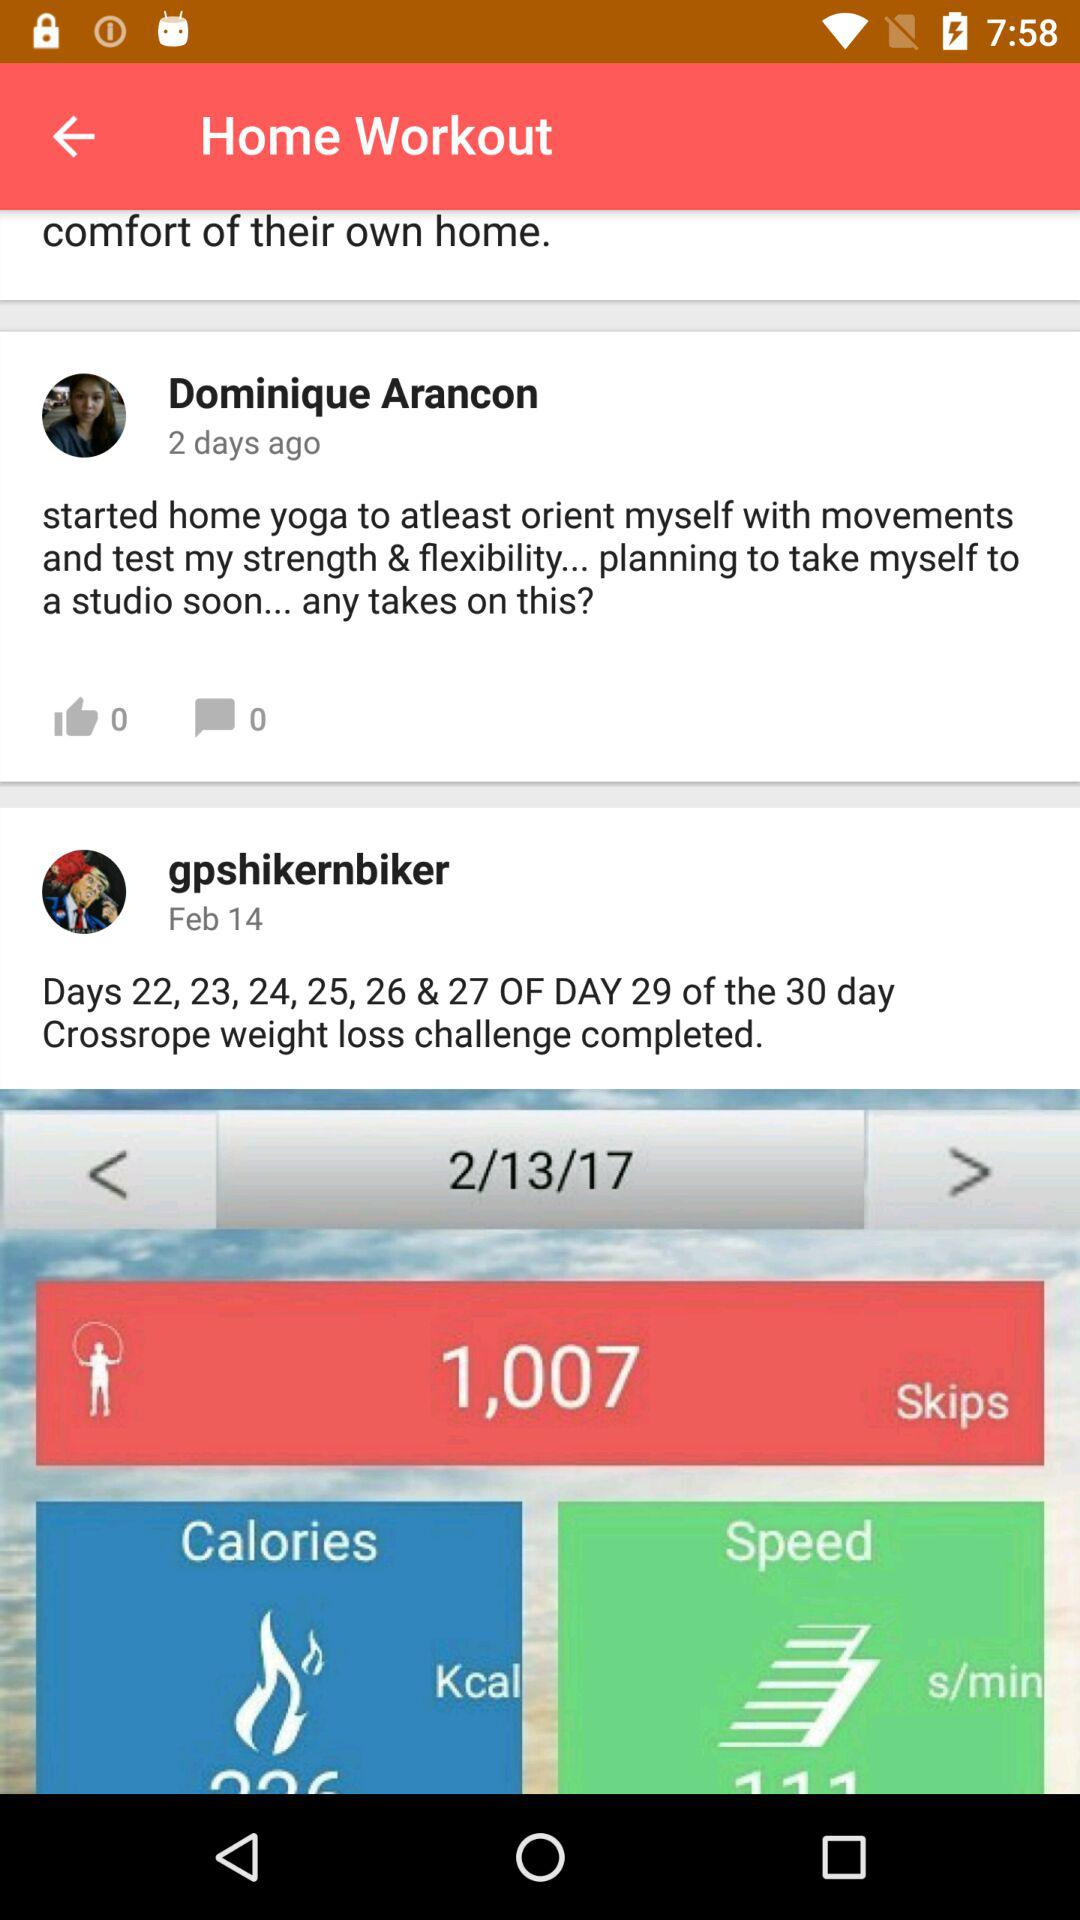How many comments are there on the post by Dominique Arancon? There are 0 comments on the post by Dominique Arancon. 